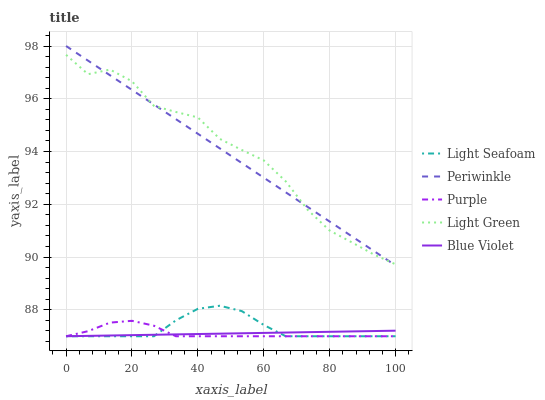Does Blue Violet have the minimum area under the curve?
Answer yes or no. Yes. Does Light Green have the maximum area under the curve?
Answer yes or no. Yes. Does Light Seafoam have the minimum area under the curve?
Answer yes or no. No. Does Light Seafoam have the maximum area under the curve?
Answer yes or no. No. Is Blue Violet the smoothest?
Answer yes or no. Yes. Is Light Green the roughest?
Answer yes or no. Yes. Is Light Seafoam the smoothest?
Answer yes or no. No. Is Light Seafoam the roughest?
Answer yes or no. No. Does Purple have the lowest value?
Answer yes or no. Yes. Does Periwinkle have the lowest value?
Answer yes or no. No. Does Periwinkle have the highest value?
Answer yes or no. Yes. Does Light Seafoam have the highest value?
Answer yes or no. No. Is Blue Violet less than Light Green?
Answer yes or no. Yes. Is Periwinkle greater than Purple?
Answer yes or no. Yes. Does Blue Violet intersect Purple?
Answer yes or no. Yes. Is Blue Violet less than Purple?
Answer yes or no. No. Is Blue Violet greater than Purple?
Answer yes or no. No. Does Blue Violet intersect Light Green?
Answer yes or no. No. 